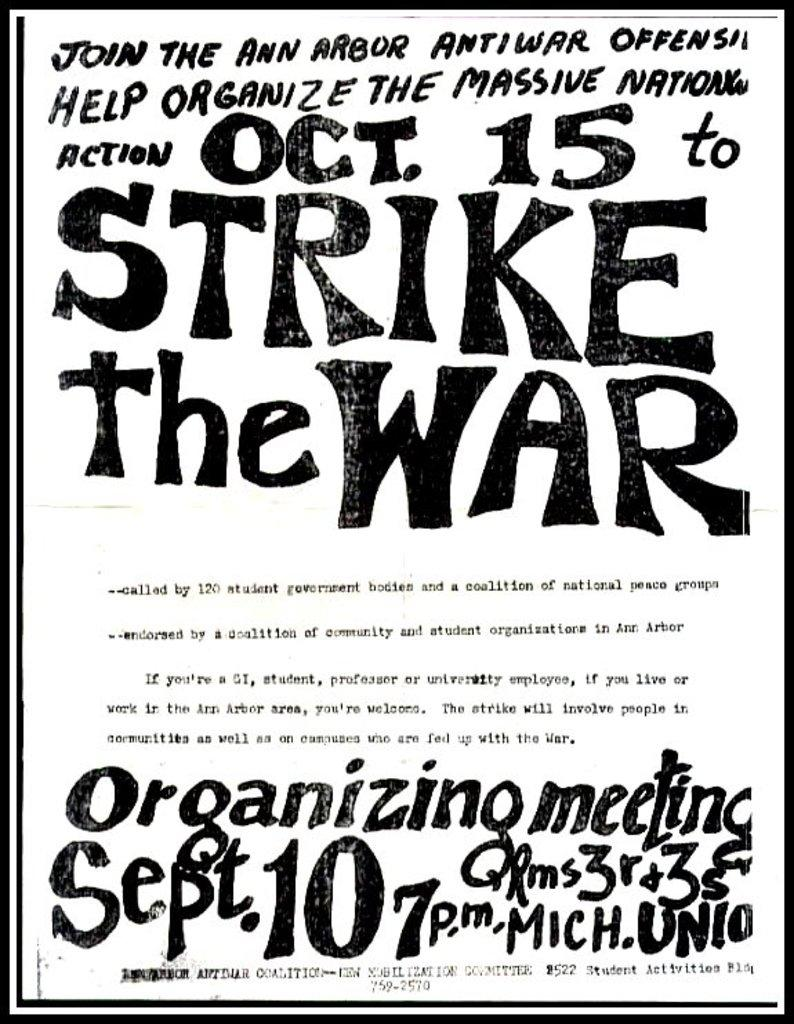Provide a one-sentence caption for the provided image. A flyer to join the STRIKE THE WAR action on October 15. 